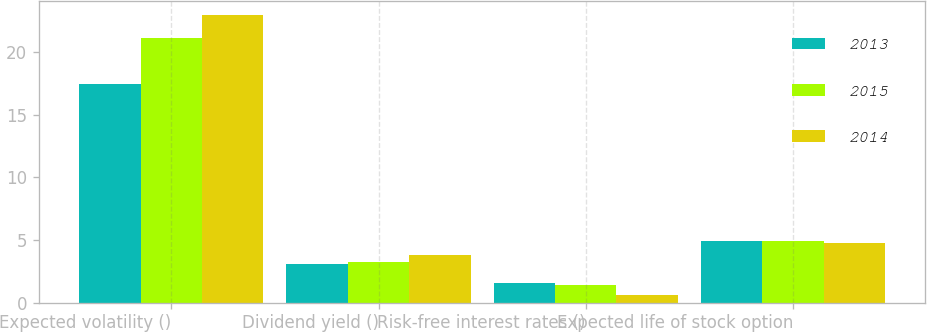Convert chart. <chart><loc_0><loc_0><loc_500><loc_500><stacked_bar_chart><ecel><fcel>Expected volatility ()<fcel>Dividend yield ()<fcel>Risk-free interest rates ()<fcel>Expected life of stock option<nl><fcel>2013<fcel>17.45<fcel>3.1<fcel>1.58<fcel>4.92<nl><fcel>2015<fcel>21.13<fcel>3.24<fcel>1.37<fcel>4.91<nl><fcel>2014<fcel>22.95<fcel>3.77<fcel>0.57<fcel>4.8<nl></chart> 